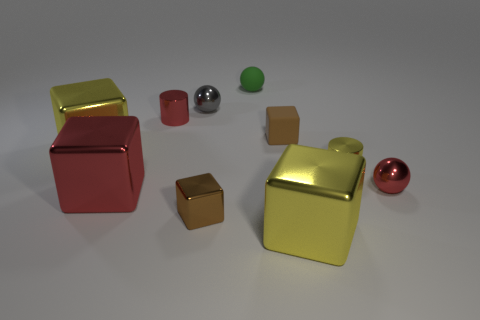What is the color of the small matte block?
Keep it short and to the point. Brown. Is there a rubber cube to the left of the large yellow block left of the green matte sphere?
Your answer should be compact. No. What number of green objects have the same size as the brown shiny thing?
Make the answer very short. 1. What number of balls are behind the yellow shiny thing that is in front of the small brown cube that is on the left side of the small green sphere?
Offer a terse response. 3. How many big blocks are to the left of the red cube and to the right of the gray shiny object?
Offer a terse response. 0. Is there anything else that has the same color as the tiny matte block?
Offer a very short reply. Yes. What number of shiny things are red balls or cyan objects?
Ensure brevity in your answer.  1. What is the tiny red object to the left of the large metal block right of the tiny shiny ball on the left side of the small green thing made of?
Your answer should be compact. Metal. The tiny brown block to the left of the small rubber ball that is right of the big red shiny thing is made of what material?
Provide a succinct answer. Metal. Is the size of the shiny sphere to the right of the small matte block the same as the green rubber ball right of the tiny gray object?
Your answer should be very brief. Yes. 